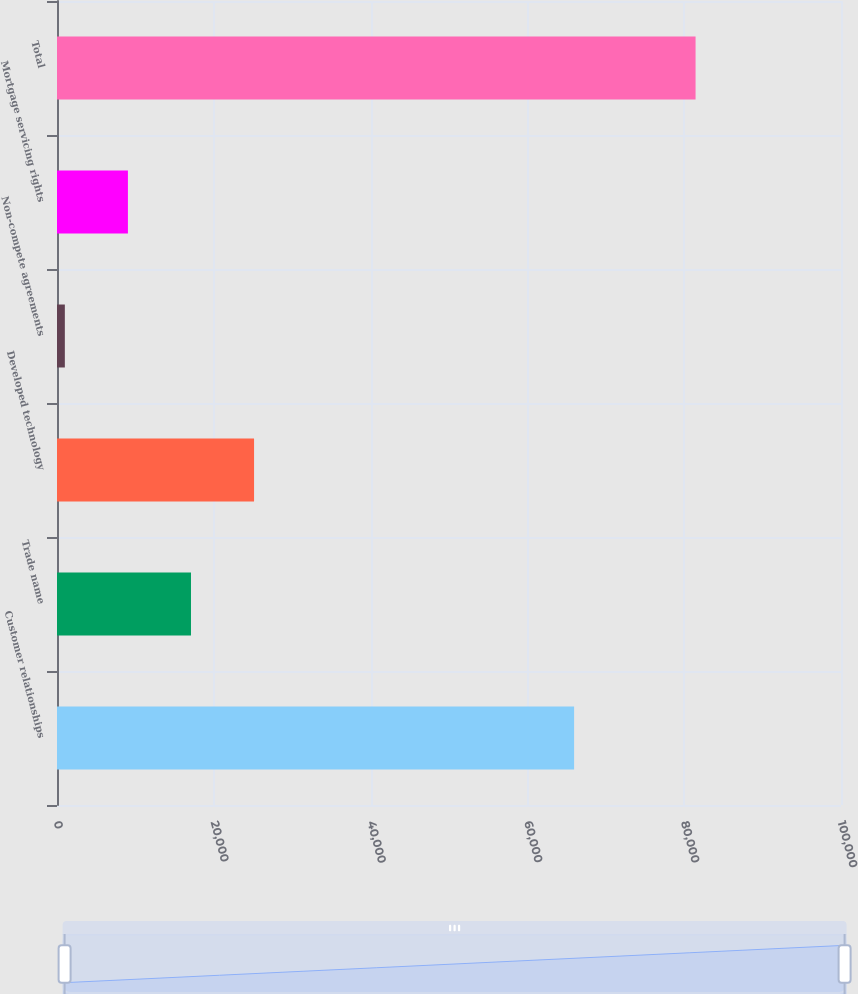Convert chart. <chart><loc_0><loc_0><loc_500><loc_500><bar_chart><fcel>Customer relationships<fcel>Trade name<fcel>Developed technology<fcel>Non-compete agreements<fcel>Mortgage servicing rights<fcel>Total<nl><fcel>65957<fcel>17090<fcel>25135<fcel>1000<fcel>9045<fcel>81450<nl></chart> 